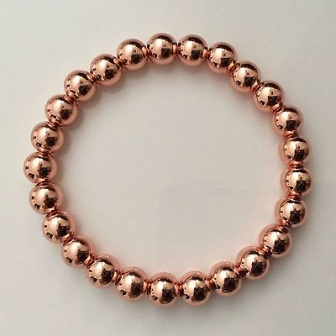Can you describe the style or type of the jewelry shown in this image? The jewelry in the image is a minimalist-style bracelet. It features 18 polished copper-colored beads that are evenly spaced and connected to form a perfect circle. The simplicity of the design highlights the elegance and sophistication of minimalist jewelry, making it a versatile accessory suitable for various occasions. How do you think one might wear this bracelet in combination with other jewelry? This minimalist bracelet can be styled in numerous ways to complement various accessories. For a chic, layered look, it can be paired with other bracelets of varying textures and sizes, such as leather bands, thin metal bangles, or beaded bracelets in complementary colors. For a more refined and elegant ensemble, it can be worn alongside a delicate wristwatch or a sleek, modern cuff. Its copper hue can harmonize beautifully with both gold and silver jewelry, allowing for numerous creative combinations. 